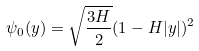<formula> <loc_0><loc_0><loc_500><loc_500>\psi _ { 0 } ( y ) = \sqrt { \frac { 3 H } { 2 } } ( 1 - H | y | ) ^ { 2 }</formula> 